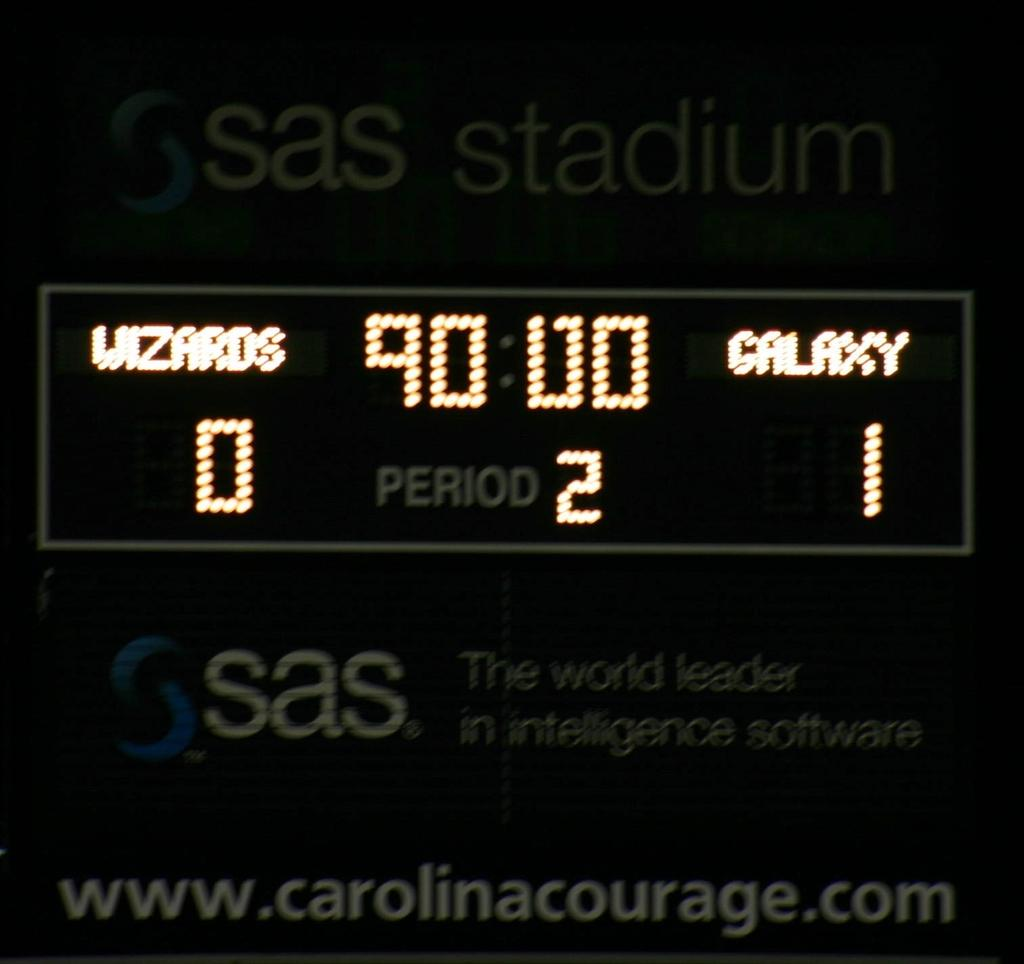<image>
Describe the image concisely. A scoreboard showing the Galaxy beating the Wizards after 90 minutes of regulation time 